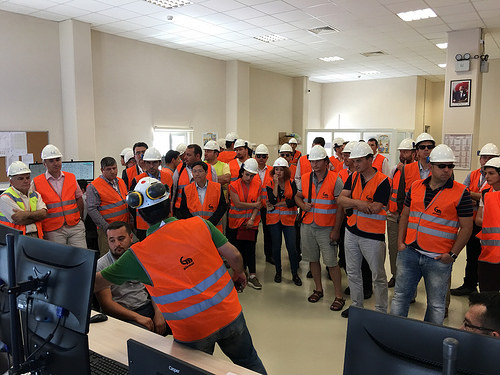<image>
Can you confirm if the man is under the celing? Yes. The man is positioned underneath the celing, with the celing above it in the vertical space. 